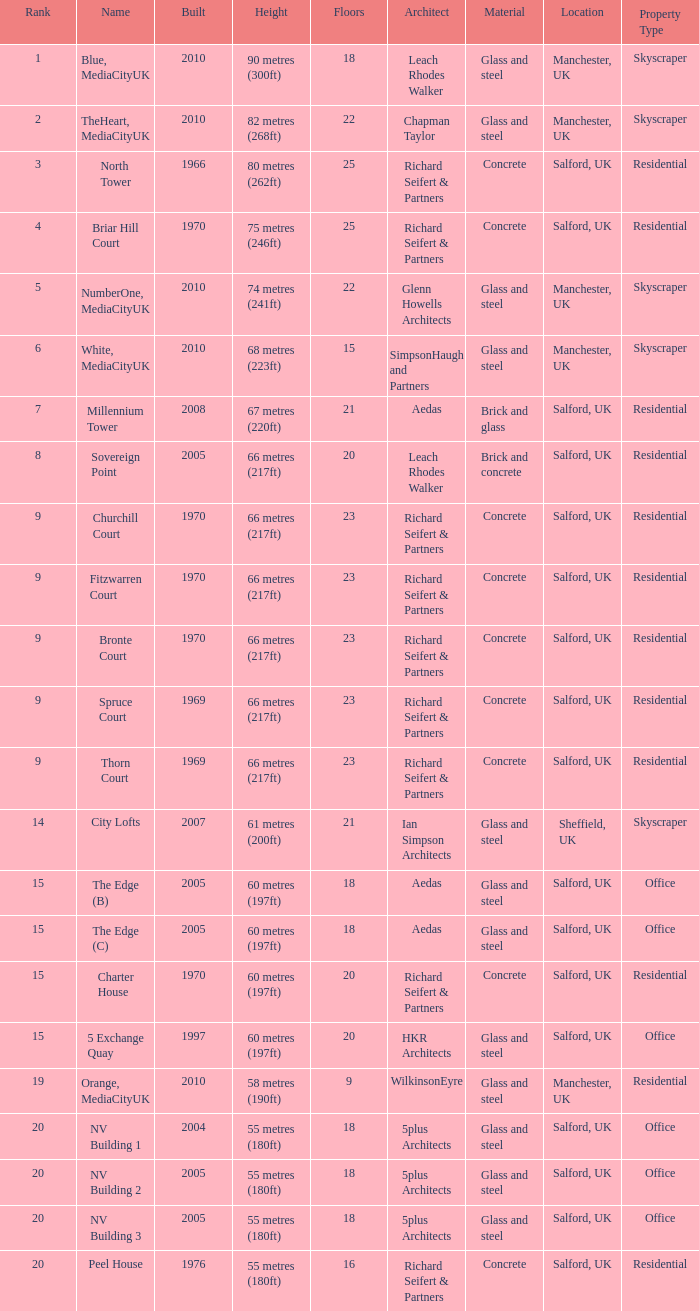What is the total number of Built, when Floors is less than 22, when Rank is less than 8, and when Name is White, Mediacityuk? 1.0. 